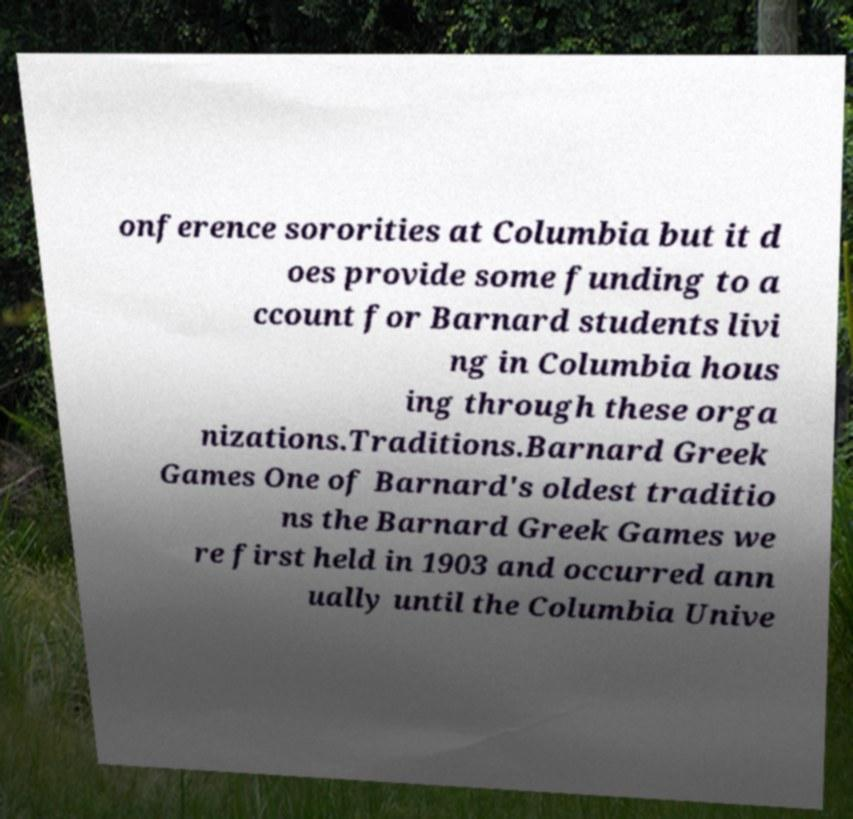Please identify and transcribe the text found in this image. onference sororities at Columbia but it d oes provide some funding to a ccount for Barnard students livi ng in Columbia hous ing through these orga nizations.Traditions.Barnard Greek Games One of Barnard's oldest traditio ns the Barnard Greek Games we re first held in 1903 and occurred ann ually until the Columbia Unive 